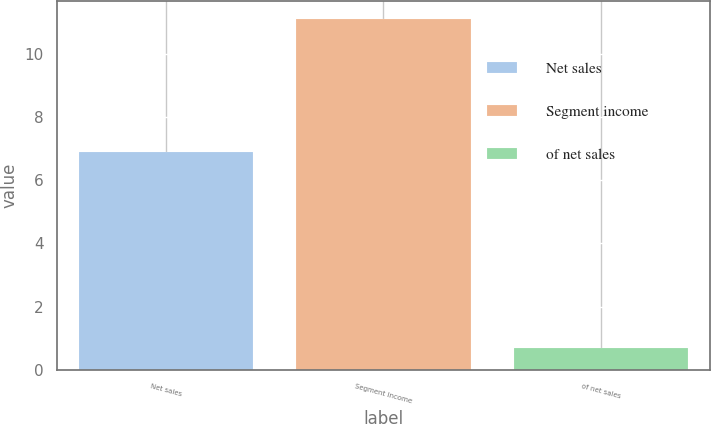<chart> <loc_0><loc_0><loc_500><loc_500><bar_chart><fcel>Net sales<fcel>Segment income<fcel>of net sales<nl><fcel>6.9<fcel>11.1<fcel>0.7<nl></chart> 